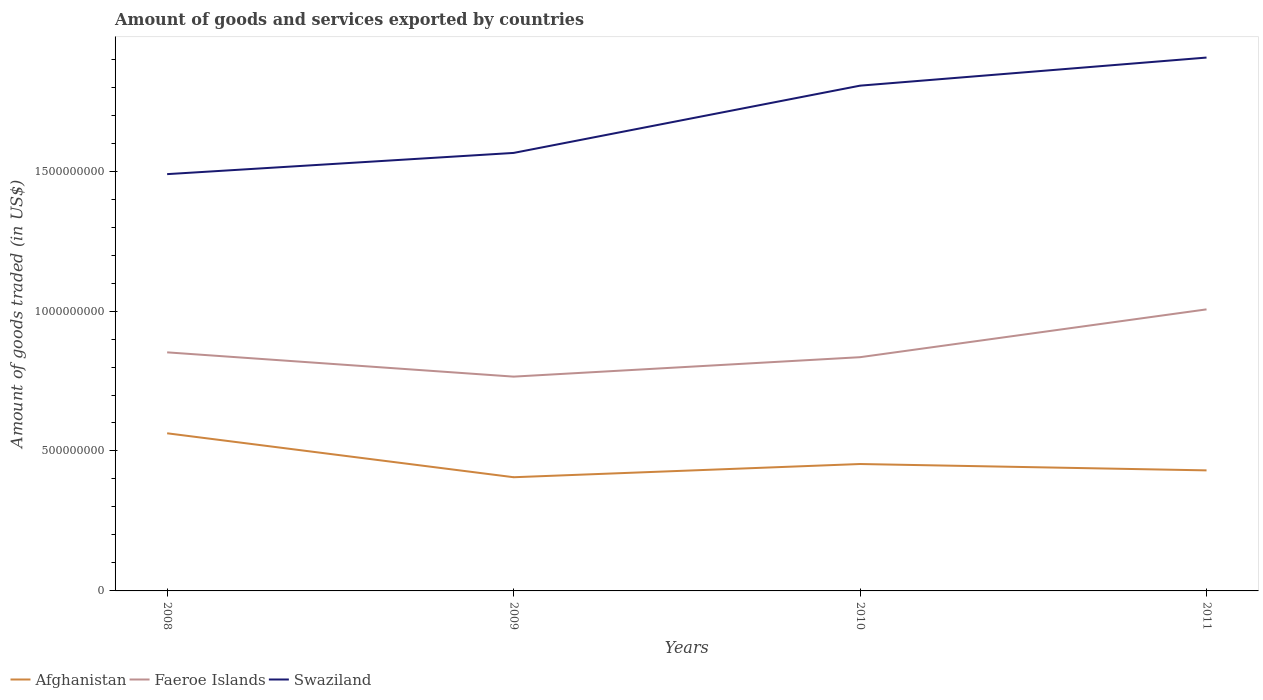Is the number of lines equal to the number of legend labels?
Give a very brief answer. Yes. Across all years, what is the maximum total amount of goods and services exported in Faeroe Islands?
Offer a very short reply. 7.66e+08. What is the total total amount of goods and services exported in Faeroe Islands in the graph?
Ensure brevity in your answer.  8.67e+07. What is the difference between the highest and the second highest total amount of goods and services exported in Faeroe Islands?
Your answer should be compact. 2.40e+08. How many years are there in the graph?
Your response must be concise. 4. How many legend labels are there?
Your answer should be compact. 3. How are the legend labels stacked?
Make the answer very short. Horizontal. What is the title of the graph?
Ensure brevity in your answer.  Amount of goods and services exported by countries. Does "Afghanistan" appear as one of the legend labels in the graph?
Offer a terse response. Yes. What is the label or title of the Y-axis?
Keep it short and to the point. Amount of goods traded (in US$). What is the Amount of goods traded (in US$) of Afghanistan in 2008?
Keep it short and to the point. 5.63e+08. What is the Amount of goods traded (in US$) of Faeroe Islands in 2008?
Ensure brevity in your answer.  8.52e+08. What is the Amount of goods traded (in US$) in Swaziland in 2008?
Ensure brevity in your answer.  1.49e+09. What is the Amount of goods traded (in US$) in Afghanistan in 2009?
Offer a terse response. 4.06e+08. What is the Amount of goods traded (in US$) in Faeroe Islands in 2009?
Your answer should be compact. 7.66e+08. What is the Amount of goods traded (in US$) of Swaziland in 2009?
Offer a very short reply. 1.56e+09. What is the Amount of goods traded (in US$) in Afghanistan in 2010?
Keep it short and to the point. 4.53e+08. What is the Amount of goods traded (in US$) in Faeroe Islands in 2010?
Provide a short and direct response. 8.35e+08. What is the Amount of goods traded (in US$) in Swaziland in 2010?
Offer a terse response. 1.81e+09. What is the Amount of goods traded (in US$) of Afghanistan in 2011?
Your answer should be very brief. 4.31e+08. What is the Amount of goods traded (in US$) of Faeroe Islands in 2011?
Give a very brief answer. 1.01e+09. What is the Amount of goods traded (in US$) in Swaziland in 2011?
Give a very brief answer. 1.91e+09. Across all years, what is the maximum Amount of goods traded (in US$) of Afghanistan?
Offer a terse response. 5.63e+08. Across all years, what is the maximum Amount of goods traded (in US$) in Faeroe Islands?
Offer a very short reply. 1.01e+09. Across all years, what is the maximum Amount of goods traded (in US$) of Swaziland?
Offer a very short reply. 1.91e+09. Across all years, what is the minimum Amount of goods traded (in US$) of Afghanistan?
Provide a succinct answer. 4.06e+08. Across all years, what is the minimum Amount of goods traded (in US$) of Faeroe Islands?
Offer a terse response. 7.66e+08. Across all years, what is the minimum Amount of goods traded (in US$) in Swaziland?
Ensure brevity in your answer.  1.49e+09. What is the total Amount of goods traded (in US$) of Afghanistan in the graph?
Provide a succinct answer. 1.85e+09. What is the total Amount of goods traded (in US$) in Faeroe Islands in the graph?
Your answer should be very brief. 3.46e+09. What is the total Amount of goods traded (in US$) of Swaziland in the graph?
Offer a very short reply. 6.77e+09. What is the difference between the Amount of goods traded (in US$) in Afghanistan in 2008 and that in 2009?
Ensure brevity in your answer.  1.57e+08. What is the difference between the Amount of goods traded (in US$) in Faeroe Islands in 2008 and that in 2009?
Your answer should be very brief. 8.67e+07. What is the difference between the Amount of goods traded (in US$) in Swaziland in 2008 and that in 2009?
Offer a terse response. -7.58e+07. What is the difference between the Amount of goods traded (in US$) of Afghanistan in 2008 and that in 2010?
Provide a short and direct response. 1.10e+08. What is the difference between the Amount of goods traded (in US$) in Faeroe Islands in 2008 and that in 2010?
Offer a very short reply. 1.73e+07. What is the difference between the Amount of goods traded (in US$) in Swaziland in 2008 and that in 2010?
Offer a very short reply. -3.16e+08. What is the difference between the Amount of goods traded (in US$) of Afghanistan in 2008 and that in 2011?
Ensure brevity in your answer.  1.32e+08. What is the difference between the Amount of goods traded (in US$) in Faeroe Islands in 2008 and that in 2011?
Make the answer very short. -1.54e+08. What is the difference between the Amount of goods traded (in US$) of Swaziland in 2008 and that in 2011?
Provide a short and direct response. -4.17e+08. What is the difference between the Amount of goods traded (in US$) of Afghanistan in 2009 and that in 2010?
Keep it short and to the point. -4.72e+07. What is the difference between the Amount of goods traded (in US$) of Faeroe Islands in 2009 and that in 2010?
Give a very brief answer. -6.94e+07. What is the difference between the Amount of goods traded (in US$) in Swaziland in 2009 and that in 2010?
Ensure brevity in your answer.  -2.40e+08. What is the difference between the Amount of goods traded (in US$) in Afghanistan in 2009 and that in 2011?
Your response must be concise. -2.45e+07. What is the difference between the Amount of goods traded (in US$) of Faeroe Islands in 2009 and that in 2011?
Your answer should be very brief. -2.40e+08. What is the difference between the Amount of goods traded (in US$) in Swaziland in 2009 and that in 2011?
Your answer should be very brief. -3.41e+08. What is the difference between the Amount of goods traded (in US$) of Afghanistan in 2010 and that in 2011?
Keep it short and to the point. 2.27e+07. What is the difference between the Amount of goods traded (in US$) of Faeroe Islands in 2010 and that in 2011?
Make the answer very short. -1.71e+08. What is the difference between the Amount of goods traded (in US$) of Swaziland in 2010 and that in 2011?
Make the answer very short. -1.00e+08. What is the difference between the Amount of goods traded (in US$) of Afghanistan in 2008 and the Amount of goods traded (in US$) of Faeroe Islands in 2009?
Provide a succinct answer. -2.02e+08. What is the difference between the Amount of goods traded (in US$) in Afghanistan in 2008 and the Amount of goods traded (in US$) in Swaziland in 2009?
Offer a very short reply. -1.00e+09. What is the difference between the Amount of goods traded (in US$) in Faeroe Islands in 2008 and the Amount of goods traded (in US$) in Swaziland in 2009?
Your answer should be compact. -7.13e+08. What is the difference between the Amount of goods traded (in US$) of Afghanistan in 2008 and the Amount of goods traded (in US$) of Faeroe Islands in 2010?
Offer a very short reply. -2.72e+08. What is the difference between the Amount of goods traded (in US$) of Afghanistan in 2008 and the Amount of goods traded (in US$) of Swaziland in 2010?
Provide a succinct answer. -1.24e+09. What is the difference between the Amount of goods traded (in US$) of Faeroe Islands in 2008 and the Amount of goods traded (in US$) of Swaziland in 2010?
Keep it short and to the point. -9.53e+08. What is the difference between the Amount of goods traded (in US$) of Afghanistan in 2008 and the Amount of goods traded (in US$) of Faeroe Islands in 2011?
Your response must be concise. -4.43e+08. What is the difference between the Amount of goods traded (in US$) in Afghanistan in 2008 and the Amount of goods traded (in US$) in Swaziland in 2011?
Offer a very short reply. -1.34e+09. What is the difference between the Amount of goods traded (in US$) in Faeroe Islands in 2008 and the Amount of goods traded (in US$) in Swaziland in 2011?
Ensure brevity in your answer.  -1.05e+09. What is the difference between the Amount of goods traded (in US$) of Afghanistan in 2009 and the Amount of goods traded (in US$) of Faeroe Islands in 2010?
Keep it short and to the point. -4.29e+08. What is the difference between the Amount of goods traded (in US$) of Afghanistan in 2009 and the Amount of goods traded (in US$) of Swaziland in 2010?
Your answer should be very brief. -1.40e+09. What is the difference between the Amount of goods traded (in US$) in Faeroe Islands in 2009 and the Amount of goods traded (in US$) in Swaziland in 2010?
Make the answer very short. -1.04e+09. What is the difference between the Amount of goods traded (in US$) in Afghanistan in 2009 and the Amount of goods traded (in US$) in Faeroe Islands in 2011?
Give a very brief answer. -6.00e+08. What is the difference between the Amount of goods traded (in US$) in Afghanistan in 2009 and the Amount of goods traded (in US$) in Swaziland in 2011?
Provide a succinct answer. -1.50e+09. What is the difference between the Amount of goods traded (in US$) of Faeroe Islands in 2009 and the Amount of goods traded (in US$) of Swaziland in 2011?
Your response must be concise. -1.14e+09. What is the difference between the Amount of goods traded (in US$) of Afghanistan in 2010 and the Amount of goods traded (in US$) of Faeroe Islands in 2011?
Give a very brief answer. -5.53e+08. What is the difference between the Amount of goods traded (in US$) of Afghanistan in 2010 and the Amount of goods traded (in US$) of Swaziland in 2011?
Offer a very short reply. -1.45e+09. What is the difference between the Amount of goods traded (in US$) in Faeroe Islands in 2010 and the Amount of goods traded (in US$) in Swaziland in 2011?
Your answer should be very brief. -1.07e+09. What is the average Amount of goods traded (in US$) of Afghanistan per year?
Your answer should be very brief. 4.63e+08. What is the average Amount of goods traded (in US$) of Faeroe Islands per year?
Your answer should be very brief. 8.65e+08. What is the average Amount of goods traded (in US$) of Swaziland per year?
Your answer should be compact. 1.69e+09. In the year 2008, what is the difference between the Amount of goods traded (in US$) in Afghanistan and Amount of goods traded (in US$) in Faeroe Islands?
Your response must be concise. -2.89e+08. In the year 2008, what is the difference between the Amount of goods traded (in US$) of Afghanistan and Amount of goods traded (in US$) of Swaziland?
Make the answer very short. -9.26e+08. In the year 2008, what is the difference between the Amount of goods traded (in US$) of Faeroe Islands and Amount of goods traded (in US$) of Swaziland?
Provide a succinct answer. -6.37e+08. In the year 2009, what is the difference between the Amount of goods traded (in US$) of Afghanistan and Amount of goods traded (in US$) of Faeroe Islands?
Your response must be concise. -3.59e+08. In the year 2009, what is the difference between the Amount of goods traded (in US$) in Afghanistan and Amount of goods traded (in US$) in Swaziland?
Provide a short and direct response. -1.16e+09. In the year 2009, what is the difference between the Amount of goods traded (in US$) in Faeroe Islands and Amount of goods traded (in US$) in Swaziland?
Your answer should be compact. -7.99e+08. In the year 2010, what is the difference between the Amount of goods traded (in US$) in Afghanistan and Amount of goods traded (in US$) in Faeroe Islands?
Your response must be concise. -3.82e+08. In the year 2010, what is the difference between the Amount of goods traded (in US$) in Afghanistan and Amount of goods traded (in US$) in Swaziland?
Offer a terse response. -1.35e+09. In the year 2010, what is the difference between the Amount of goods traded (in US$) of Faeroe Islands and Amount of goods traded (in US$) of Swaziland?
Offer a terse response. -9.70e+08. In the year 2011, what is the difference between the Amount of goods traded (in US$) in Afghanistan and Amount of goods traded (in US$) in Faeroe Islands?
Your answer should be compact. -5.75e+08. In the year 2011, what is the difference between the Amount of goods traded (in US$) in Afghanistan and Amount of goods traded (in US$) in Swaziland?
Keep it short and to the point. -1.47e+09. In the year 2011, what is the difference between the Amount of goods traded (in US$) in Faeroe Islands and Amount of goods traded (in US$) in Swaziland?
Provide a succinct answer. -9.00e+08. What is the ratio of the Amount of goods traded (in US$) in Afghanistan in 2008 to that in 2009?
Provide a succinct answer. 1.39. What is the ratio of the Amount of goods traded (in US$) of Faeroe Islands in 2008 to that in 2009?
Offer a very short reply. 1.11. What is the ratio of the Amount of goods traded (in US$) in Swaziland in 2008 to that in 2009?
Offer a terse response. 0.95. What is the ratio of the Amount of goods traded (in US$) in Afghanistan in 2008 to that in 2010?
Provide a succinct answer. 1.24. What is the ratio of the Amount of goods traded (in US$) of Faeroe Islands in 2008 to that in 2010?
Give a very brief answer. 1.02. What is the ratio of the Amount of goods traded (in US$) of Swaziland in 2008 to that in 2010?
Keep it short and to the point. 0.82. What is the ratio of the Amount of goods traded (in US$) in Afghanistan in 2008 to that in 2011?
Keep it short and to the point. 1.31. What is the ratio of the Amount of goods traded (in US$) of Faeroe Islands in 2008 to that in 2011?
Make the answer very short. 0.85. What is the ratio of the Amount of goods traded (in US$) in Swaziland in 2008 to that in 2011?
Your response must be concise. 0.78. What is the ratio of the Amount of goods traded (in US$) of Afghanistan in 2009 to that in 2010?
Ensure brevity in your answer.  0.9. What is the ratio of the Amount of goods traded (in US$) in Faeroe Islands in 2009 to that in 2010?
Your response must be concise. 0.92. What is the ratio of the Amount of goods traded (in US$) of Swaziland in 2009 to that in 2010?
Your response must be concise. 0.87. What is the ratio of the Amount of goods traded (in US$) in Afghanistan in 2009 to that in 2011?
Keep it short and to the point. 0.94. What is the ratio of the Amount of goods traded (in US$) in Faeroe Islands in 2009 to that in 2011?
Your response must be concise. 0.76. What is the ratio of the Amount of goods traded (in US$) of Swaziland in 2009 to that in 2011?
Make the answer very short. 0.82. What is the ratio of the Amount of goods traded (in US$) in Afghanistan in 2010 to that in 2011?
Your answer should be very brief. 1.05. What is the ratio of the Amount of goods traded (in US$) of Faeroe Islands in 2010 to that in 2011?
Make the answer very short. 0.83. What is the ratio of the Amount of goods traded (in US$) of Swaziland in 2010 to that in 2011?
Offer a very short reply. 0.95. What is the difference between the highest and the second highest Amount of goods traded (in US$) in Afghanistan?
Your response must be concise. 1.10e+08. What is the difference between the highest and the second highest Amount of goods traded (in US$) in Faeroe Islands?
Provide a succinct answer. 1.54e+08. What is the difference between the highest and the second highest Amount of goods traded (in US$) in Swaziland?
Give a very brief answer. 1.00e+08. What is the difference between the highest and the lowest Amount of goods traded (in US$) of Afghanistan?
Your answer should be compact. 1.57e+08. What is the difference between the highest and the lowest Amount of goods traded (in US$) in Faeroe Islands?
Ensure brevity in your answer.  2.40e+08. What is the difference between the highest and the lowest Amount of goods traded (in US$) of Swaziland?
Ensure brevity in your answer.  4.17e+08. 